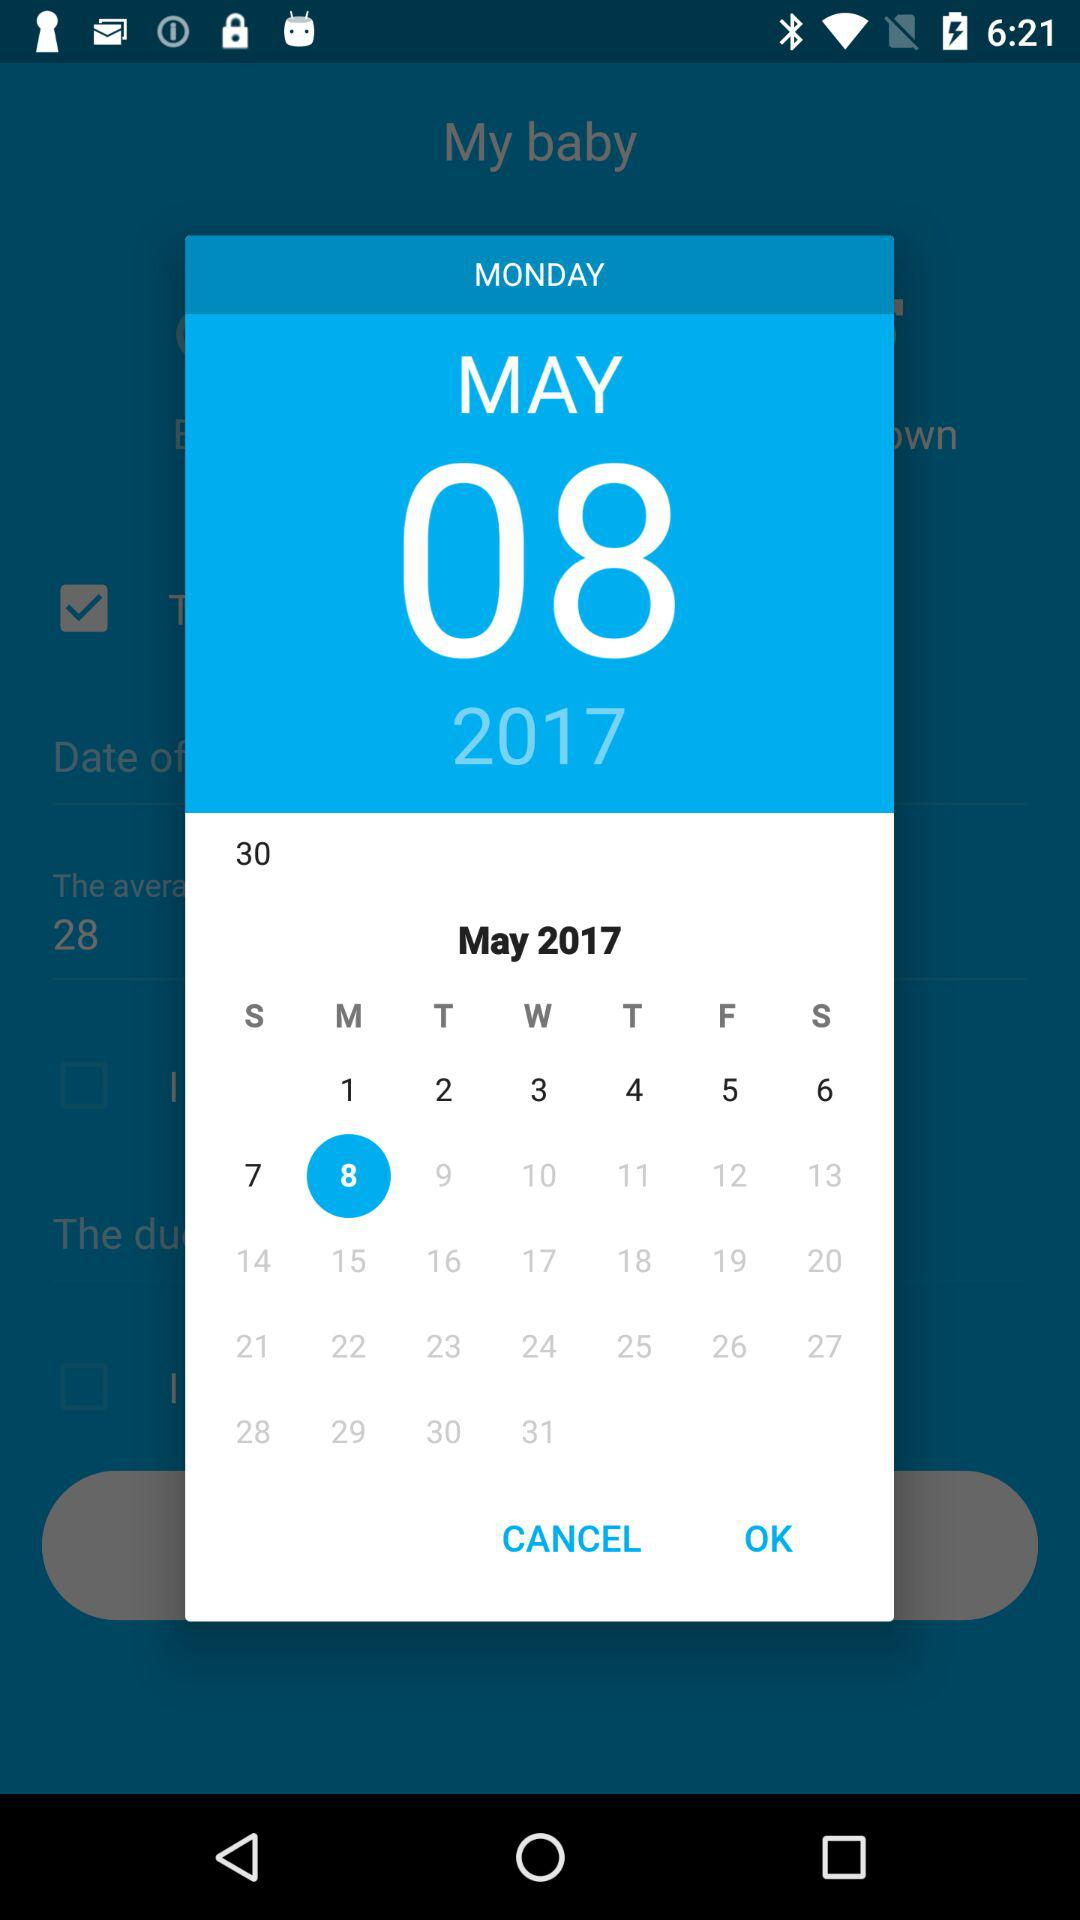What day is it on May 8th, 2017? The day is Monday. 